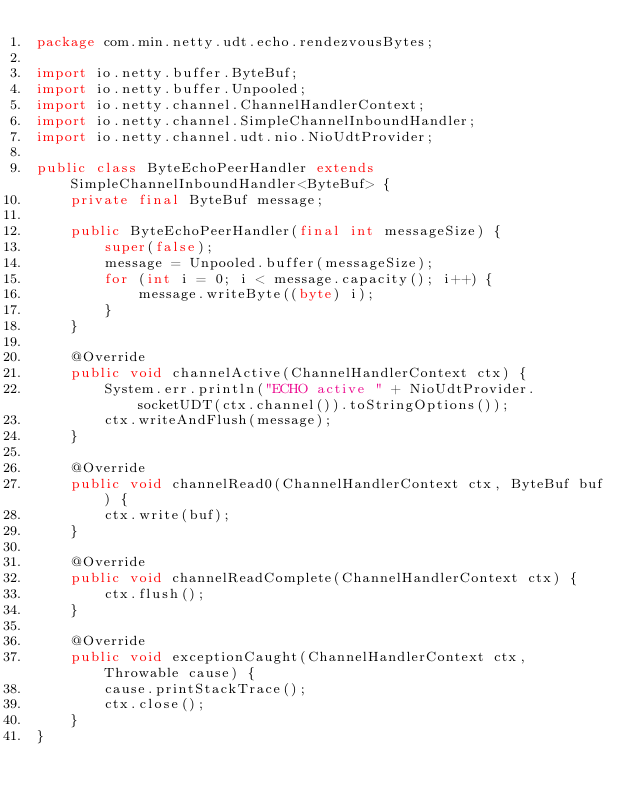<code> <loc_0><loc_0><loc_500><loc_500><_Java_>package com.min.netty.udt.echo.rendezvousBytes;

import io.netty.buffer.ByteBuf;
import io.netty.buffer.Unpooled;
import io.netty.channel.ChannelHandlerContext;
import io.netty.channel.SimpleChannelInboundHandler;
import io.netty.channel.udt.nio.NioUdtProvider;

public class ByteEchoPeerHandler extends SimpleChannelInboundHandler<ByteBuf> {
	private final ByteBuf message;
	
	public ByteEchoPeerHandler(final int messageSize) {
		super(false);
		message = Unpooled.buffer(messageSize);
		for (int i = 0; i < message.capacity(); i++) {
			message.writeByte((byte) i);
		}
	}
	
	@Override
	public void channelActive(ChannelHandlerContext ctx) {
		System.err.println("ECHO active " + NioUdtProvider.socketUDT(ctx.channel()).toStringOptions());
		ctx.writeAndFlush(message);
	}
	
	@Override
	public void channelRead0(ChannelHandlerContext ctx, ByteBuf buf) {
		ctx.write(buf);
	}
	
	@Override
	public void channelReadComplete(ChannelHandlerContext ctx) {
		ctx.flush();
	}
	
	@Override
	public void exceptionCaught(ChannelHandlerContext ctx, Throwable cause) {
		cause.printStackTrace();
		ctx.close();
	}
}
</code> 